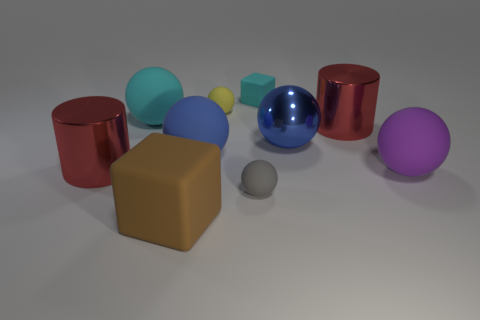Subtract all cyan balls. How many balls are left? 5 Subtract all gray matte spheres. How many spheres are left? 5 Subtract all purple spheres. Subtract all cyan cubes. How many spheres are left? 5 Subtract all cylinders. How many objects are left? 8 Add 8 blue rubber spheres. How many blue rubber spheres are left? 9 Add 5 blue cylinders. How many blue cylinders exist? 5 Subtract 0 blue blocks. How many objects are left? 10 Subtract all large rubber blocks. Subtract all tiny yellow spheres. How many objects are left? 8 